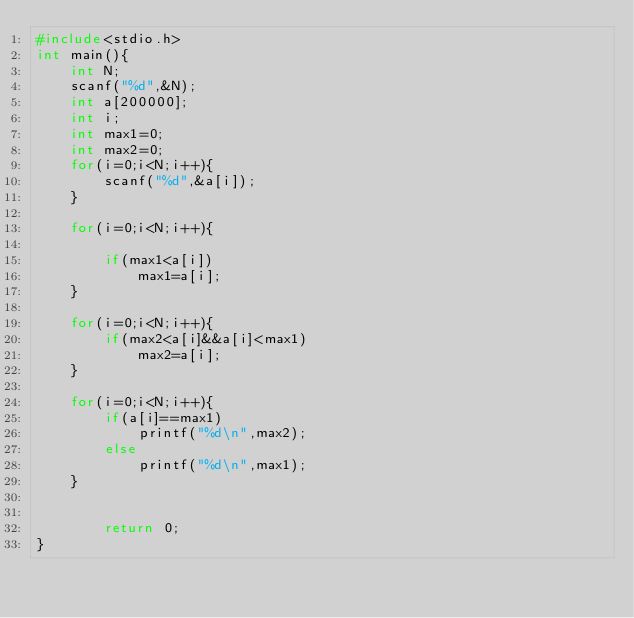<code> <loc_0><loc_0><loc_500><loc_500><_C_>#include<stdio.h>
int main(){
	int N;
	scanf("%d",&N);
	int a[200000];
	int i;
	int max1=0;
	int max2=0;
	for(i=0;i<N;i++){
		scanf("%d",&a[i]);
	}
	
	for(i=0;i<N;i++){
		
		if(max1<a[i])
			max1=a[i];
	}
	
	for(i=0;i<N;i++){
		if(max2<a[i]&&a[i]<max1)
			max2=a[i];
	}
	
	for(i=0;i<N;i++){
		if(a[i]==max1)
			printf("%d\n",max2);
		else
			printf("%d\n",max1);
	}
	
	
		return 0;
}

	
		</code> 